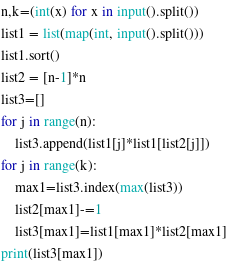<code> <loc_0><loc_0><loc_500><loc_500><_Python_>n,k=(int(x) for x in input().split())
list1 = list(map(int, input().split()))
list1.sort()
list2 = [n-1]*n
list3=[]
for j in range(n):
	list3.append(list1[j]*list1[list2[j]])
for j in range(k):
	max1=list3.index(max(list3))
	list2[max1]-=1
	list3[max1]=list1[max1]*list2[max1]
print(list3[max1])</code> 